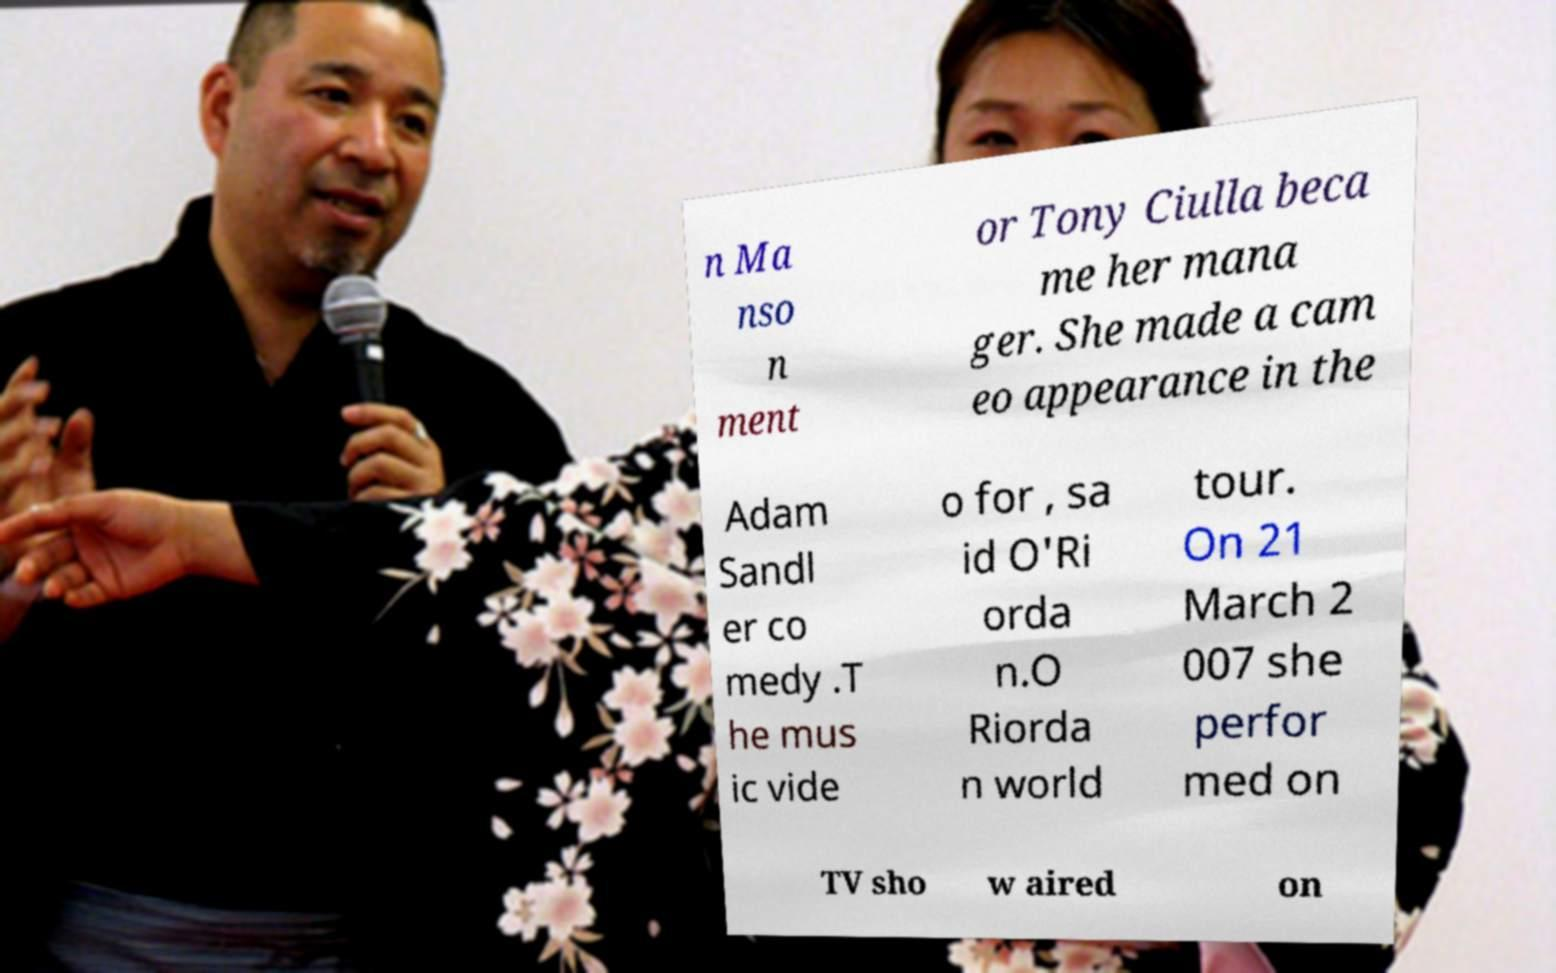Could you assist in decoding the text presented in this image and type it out clearly? n Ma nso n ment or Tony Ciulla beca me her mana ger. She made a cam eo appearance in the Adam Sandl er co medy .T he mus ic vide o for , sa id O'Ri orda n.O Riorda n world tour. On 21 March 2 007 she perfor med on TV sho w aired on 